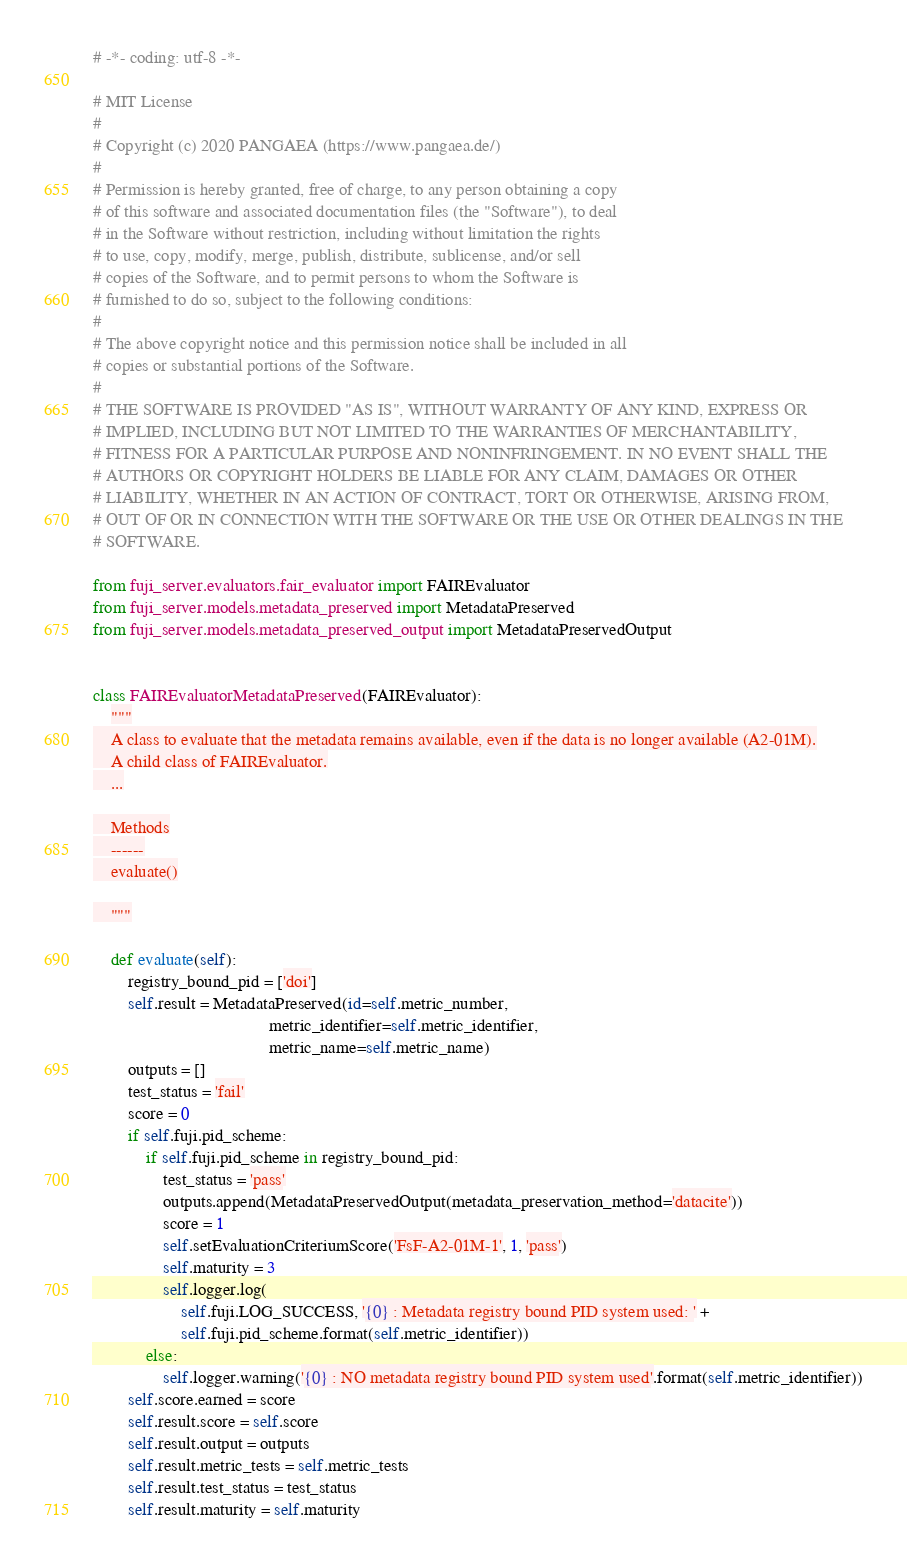Convert code to text. <code><loc_0><loc_0><loc_500><loc_500><_Python_># -*- coding: utf-8 -*-

# MIT License
#
# Copyright (c) 2020 PANGAEA (https://www.pangaea.de/)
#
# Permission is hereby granted, free of charge, to any person obtaining a copy
# of this software and associated documentation files (the "Software"), to deal
# in the Software without restriction, including without limitation the rights
# to use, copy, modify, merge, publish, distribute, sublicense, and/or sell
# copies of the Software, and to permit persons to whom the Software is
# furnished to do so, subject to the following conditions:
#
# The above copyright notice and this permission notice shall be included in all
# copies or substantial portions of the Software.
#
# THE SOFTWARE IS PROVIDED "AS IS", WITHOUT WARRANTY OF ANY KIND, EXPRESS OR
# IMPLIED, INCLUDING BUT NOT LIMITED TO THE WARRANTIES OF MERCHANTABILITY,
# FITNESS FOR A PARTICULAR PURPOSE AND NONINFRINGEMENT. IN NO EVENT SHALL THE
# AUTHORS OR COPYRIGHT HOLDERS BE LIABLE FOR ANY CLAIM, DAMAGES OR OTHER
# LIABILITY, WHETHER IN AN ACTION OF CONTRACT, TORT OR OTHERWISE, ARISING FROM,
# OUT OF OR IN CONNECTION WITH THE SOFTWARE OR THE USE OR OTHER DEALINGS IN THE
# SOFTWARE.

from fuji_server.evaluators.fair_evaluator import FAIREvaluator
from fuji_server.models.metadata_preserved import MetadataPreserved
from fuji_server.models.metadata_preserved_output import MetadataPreservedOutput


class FAIREvaluatorMetadataPreserved(FAIREvaluator):
    """
    A class to evaluate that the metadata remains available, even if the data is no longer available (A2-01M).
    A child class of FAIREvaluator.
    ...

    Methods
    ------
    evaluate()

    """

    def evaluate(self):
        registry_bound_pid = ['doi']
        self.result = MetadataPreserved(id=self.metric_number,
                                        metric_identifier=self.metric_identifier,
                                        metric_name=self.metric_name)
        outputs = []
        test_status = 'fail'
        score = 0
        if self.fuji.pid_scheme:
            if self.fuji.pid_scheme in registry_bound_pid:
                test_status = 'pass'
                outputs.append(MetadataPreservedOutput(metadata_preservation_method='datacite'))
                score = 1
                self.setEvaluationCriteriumScore('FsF-A2-01M-1', 1, 'pass')
                self.maturity = 3
                self.logger.log(
                    self.fuji.LOG_SUCCESS, '{0} : Metadata registry bound PID system used: ' +
                    self.fuji.pid_scheme.format(self.metric_identifier))
            else:
                self.logger.warning('{0} : NO metadata registry bound PID system used'.format(self.metric_identifier))
        self.score.earned = score
        self.result.score = self.score
        self.result.output = outputs
        self.result.metric_tests = self.metric_tests
        self.result.test_status = test_status
        self.result.maturity = self.maturity
</code> 